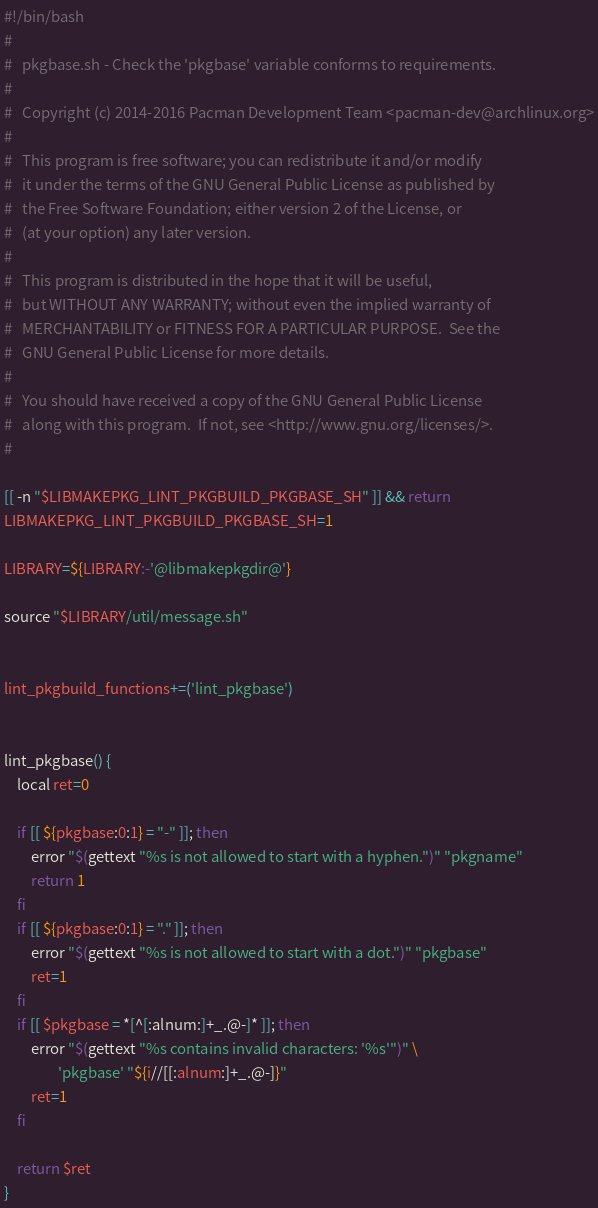Convert code to text. <code><loc_0><loc_0><loc_500><loc_500><_Bash_>#!/bin/bash
#
#   pkgbase.sh - Check the 'pkgbase' variable conforms to requirements.
#
#   Copyright (c) 2014-2016 Pacman Development Team <pacman-dev@archlinux.org>
#
#   This program is free software; you can redistribute it and/or modify
#   it under the terms of the GNU General Public License as published by
#   the Free Software Foundation; either version 2 of the License, or
#   (at your option) any later version.
#
#   This program is distributed in the hope that it will be useful,
#   but WITHOUT ANY WARRANTY; without even the implied warranty of
#   MERCHANTABILITY or FITNESS FOR A PARTICULAR PURPOSE.  See the
#   GNU General Public License for more details.
#
#   You should have received a copy of the GNU General Public License
#   along with this program.  If not, see <http://www.gnu.org/licenses/>.
#

[[ -n "$LIBMAKEPKG_LINT_PKGBUILD_PKGBASE_SH" ]] && return
LIBMAKEPKG_LINT_PKGBUILD_PKGBASE_SH=1

LIBRARY=${LIBRARY:-'@libmakepkgdir@'}

source "$LIBRARY/util/message.sh"


lint_pkgbuild_functions+=('lint_pkgbase')


lint_pkgbase() {
	local ret=0

	if [[ ${pkgbase:0:1} = "-" ]]; then
		error "$(gettext "%s is not allowed to start with a hyphen.")" "pkgname"
		return 1
	fi
	if [[ ${pkgbase:0:1} = "." ]]; then
		error "$(gettext "%s is not allowed to start with a dot.")" "pkgbase"
		ret=1
	fi
	if [[ $pkgbase = *[^[:alnum:]+_.@-]* ]]; then
		error "$(gettext "%s contains invalid characters: '%s'")" \
				'pkgbase' "${i//[[:alnum:]+_.@-]}"
		ret=1
	fi

	return $ret
}
</code> 